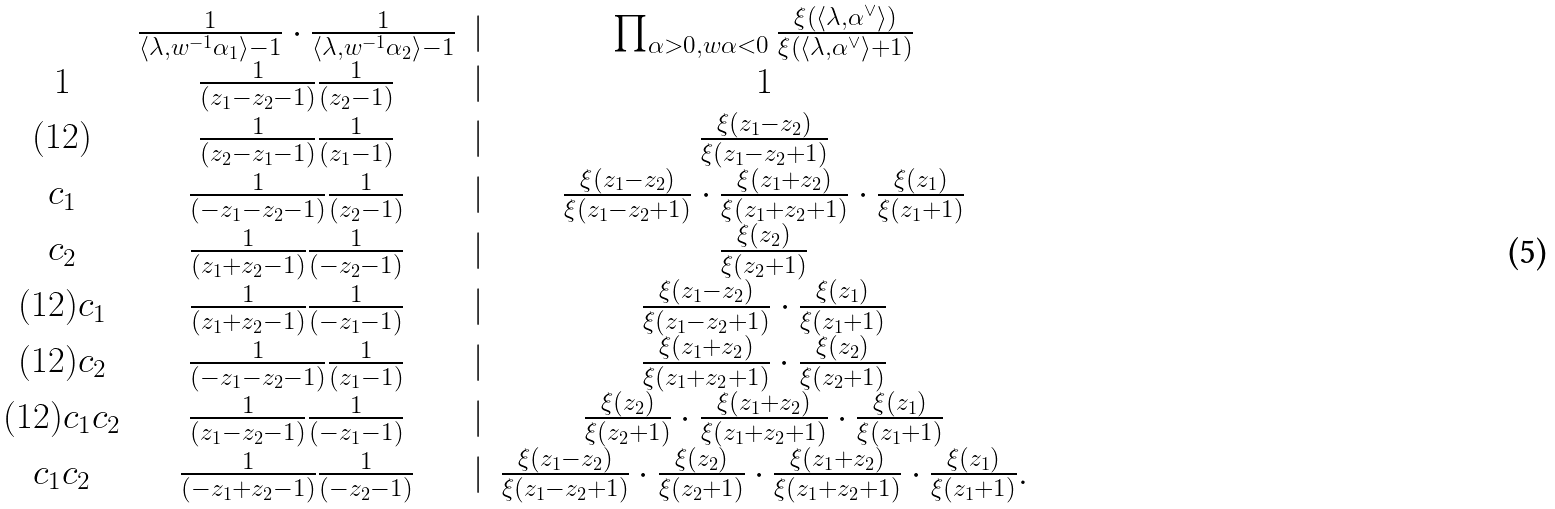<formula> <loc_0><loc_0><loc_500><loc_500>\begin{matrix} & \frac { 1 } { \langle \lambda , w ^ { - 1 } \alpha _ { 1 } \rangle - 1 } \cdot \frac { 1 } { \langle \lambda , w ^ { - 1 } \alpha _ { 2 } \rangle - 1 } & | & \prod _ { \alpha > 0 , w \alpha < 0 } \frac { \xi \left ( \langle \lambda , \alpha ^ { \vee } \rangle \right ) } { \xi \left ( \langle \lambda , \alpha ^ { \vee } \rangle + 1 \right ) } \\ 1 & \frac { 1 } { ( z _ { 1 } - z _ { 2 } - 1 ) } \frac { 1 } { ( z _ { 2 } - 1 ) } & | & 1 \\ ( 1 2 ) & \frac { 1 } { ( z _ { 2 } - z _ { 1 } - 1 ) } \frac { 1 } { ( z _ { 1 } - 1 ) } & | & \frac { \xi ( z _ { 1 } - z _ { 2 } ) } { \xi ( z _ { 1 } - z _ { 2 } + 1 ) } \\ c _ { 1 } & \frac { 1 } { ( - z _ { 1 } - z _ { 2 } - 1 ) } \frac { 1 } { ( z _ { 2 } - 1 ) } & | & \frac { \xi ( z _ { 1 } - z _ { 2 } ) } { \xi ( z _ { 1 } - z _ { 2 } + 1 ) } \cdot \frac { \xi ( z _ { 1 } + z _ { 2 } ) } { \xi ( z _ { 1 } + z _ { 2 } + 1 ) } \cdot \frac { \xi ( z _ { 1 } ) } { \xi ( z _ { 1 } + 1 ) } \\ c _ { 2 } & \frac { 1 } { ( z _ { 1 } + z _ { 2 } - 1 ) } \frac { 1 } { ( - z _ { 2 } - 1 ) } & | & \frac { \xi ( z _ { 2 } ) } { \xi ( z _ { 2 } + 1 ) } \\ ( 1 2 ) c _ { 1 } & \frac { 1 } { ( z _ { 1 } + z _ { 2 } - 1 ) } \frac { 1 } { ( - z _ { 1 } - 1 ) } & | & \frac { \xi ( z _ { 1 } - z _ { 2 } ) } { \xi ( z _ { 1 } - z _ { 2 } + 1 ) } \cdot \frac { \xi ( z _ { 1 } ) } { \xi ( z _ { 1 } + 1 ) } \\ ( 1 2 ) c _ { 2 } & \frac { 1 } { ( - z _ { 1 } - z _ { 2 } - 1 ) } \frac { 1 } { ( z _ { 1 } - 1 ) } & | & \frac { \xi ( z _ { 1 } + z _ { 2 } ) } { \xi ( z _ { 1 } + z _ { 2 } + 1 ) } \cdot \frac { \xi ( z _ { 2 } ) } { \xi ( z _ { 2 } + 1 ) } \\ ( 1 2 ) c _ { 1 } c _ { 2 } & \frac { 1 } { ( z _ { 1 } - z _ { 2 } - 1 ) } \frac { 1 } { ( - z _ { 1 } - 1 ) } & | & \frac { \xi ( z _ { 2 } ) } { \xi ( z _ { 2 } + 1 ) } \cdot \frac { \xi ( z _ { 1 } + z _ { 2 } ) } { \xi ( z _ { 1 } + z _ { 2 } + 1 ) } \cdot \frac { \xi ( z _ { 1 } ) } { \xi ( z _ { 1 } + 1 ) } \\ c _ { 1 } c _ { 2 } & \frac { 1 } { ( - z _ { 1 } + z _ { 2 } - 1 ) } \frac { 1 } { ( - z _ { 2 } - 1 ) } & | & \frac { \xi ( z _ { 1 } - z _ { 2 } ) } { \xi ( z _ { 1 } - z _ { 2 } + 1 ) } \cdot \frac { \xi ( z _ { 2 } ) } { \xi ( z _ { 2 } + 1 ) } \cdot \frac { \xi ( z _ { 1 } + z _ { 2 } ) } { \xi ( z _ { 1 } + z _ { 2 } + 1 ) } \cdot \frac { \xi ( z _ { 1 } ) } { \xi ( z _ { 1 } + 1 ) } . \end{matrix}</formula> 